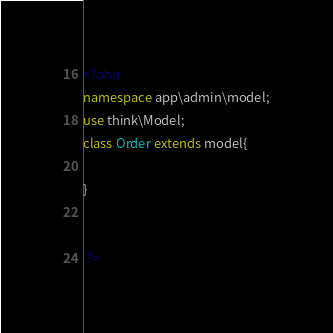Convert code to text. <code><loc_0><loc_0><loc_500><loc_500><_PHP_><?php 
namespace app\admin\model;
use think\Model;
class Order extends model{

}


 ?></code> 